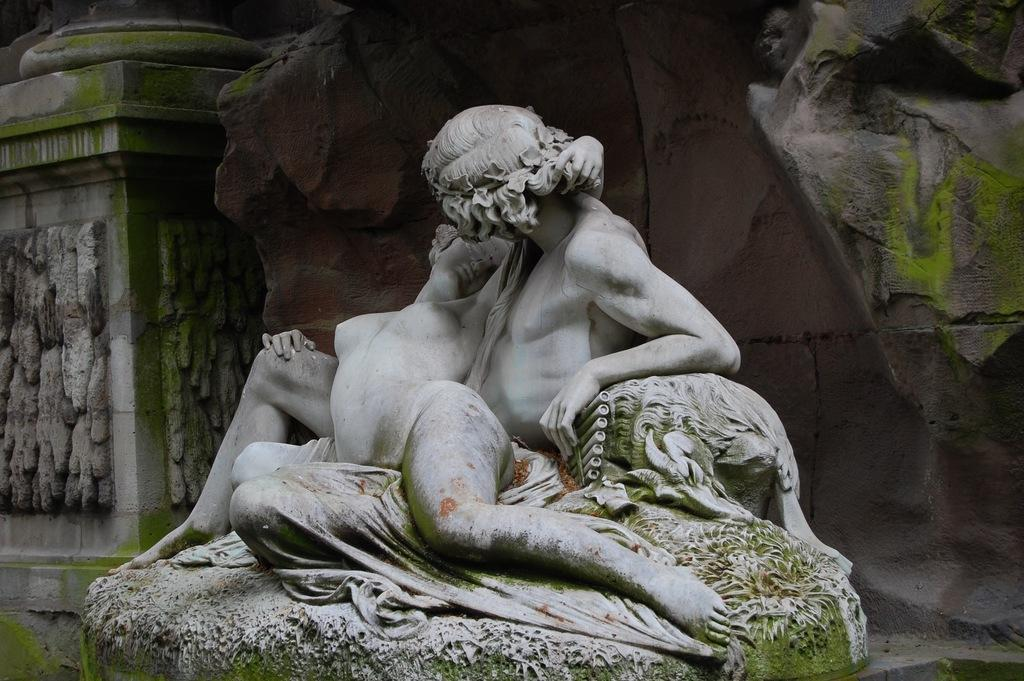What is the main subject of the image? The main subject of the image is a statue of two persons. What colors are used for the statue? The statue is green and white in color. What can be seen in the background of the image? There is a huge rock and a pillar in the background of the image. What is the color of the pillar? The pillar is ash and green in color. How many feet are visible on the statue in the image? The image does not show the feet of the persons depicted in the statue, so it is not possible to determine the number of feet visible. 